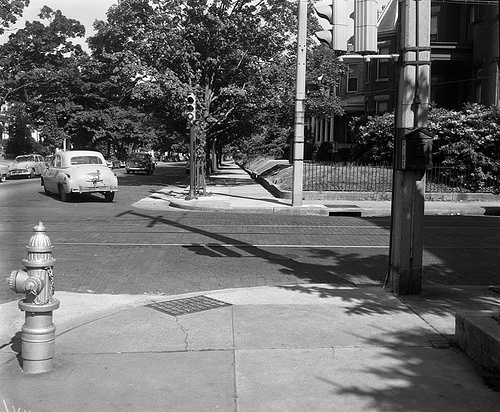Describe the objects in this image and their specific colors. I can see fire hydrant in black, darkgray, lightgray, and gray tones, car in black, lightgray, gray, and darkgray tones, traffic light in black, lightgray, darkgray, and gray tones, traffic light in black and gray tones, and car in black, darkgray, gray, and lightgray tones in this image. 